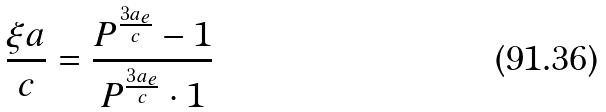<formula> <loc_0><loc_0><loc_500><loc_500>\frac { \xi a } { c } = \frac { P ^ { \frac { 3 a _ { e } } { c } } - 1 } { P ^ { \frac { 3 a _ { e } } { c } } \cdot 1 }</formula> 